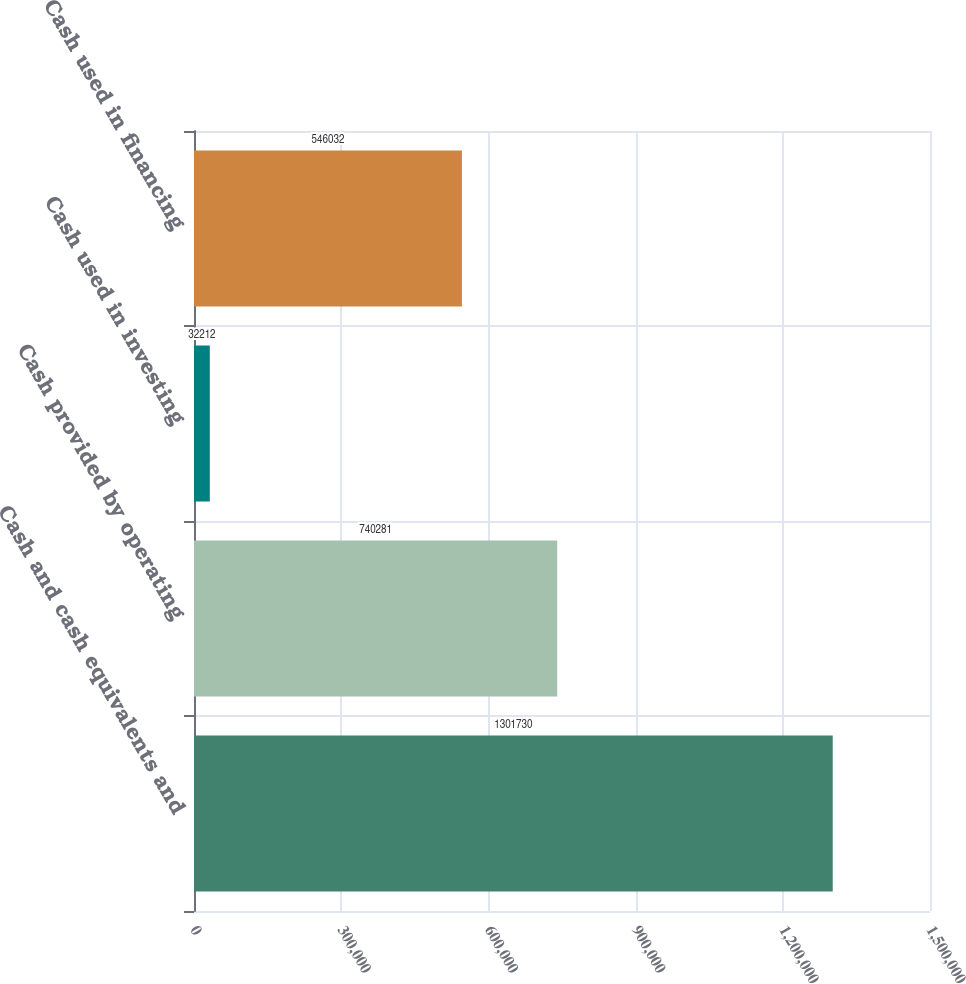Convert chart. <chart><loc_0><loc_0><loc_500><loc_500><bar_chart><fcel>Cash and cash equivalents and<fcel>Cash provided by operating<fcel>Cash used in investing<fcel>Cash used in financing<nl><fcel>1.30173e+06<fcel>740281<fcel>32212<fcel>546032<nl></chart> 